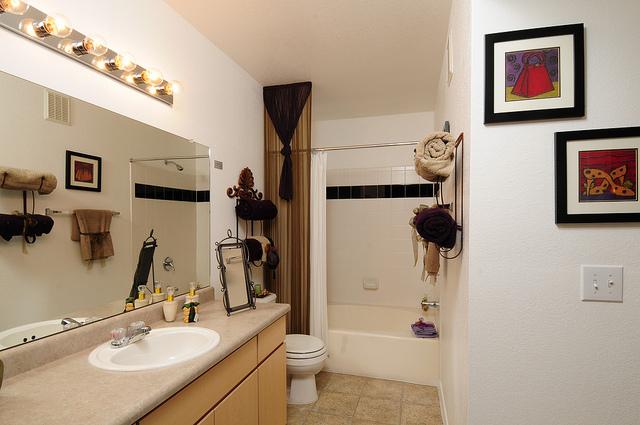What is the color theme of the decor?
Answer briefly. White. What kind of picture are on the wall?
Be succinct. Art. How many paintings are there?
Keep it brief. 3. 